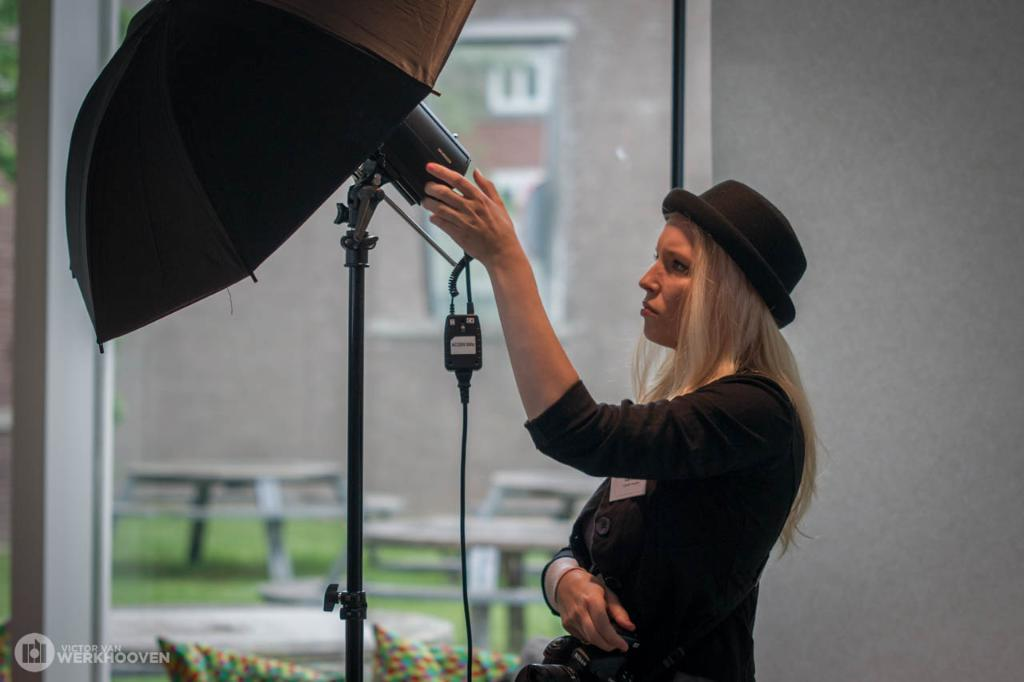What is the main subject of the image? The main subject of the image is a woman. What is the woman wearing? The woman is wearing a black hat and a black dress. What is the woman's hair color? The woman has blonde hair. What other objects can be seen in the image? There is a black umbrella, a stand, a wire, cushions, and a glass window in the image. What type of noise can be heard coming from the glass window in the image? There is no indication of any noise in the image, as it is a still photograph. 